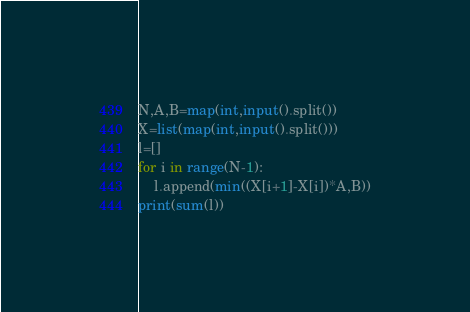Convert code to text. <code><loc_0><loc_0><loc_500><loc_500><_Python_>N,A,B=map(int,input().split())
X=list(map(int,input().split()))
l=[]
for i in range(N-1):
    l.append(min((X[i+1]-X[i])*A,B))
print(sum(l))
</code> 